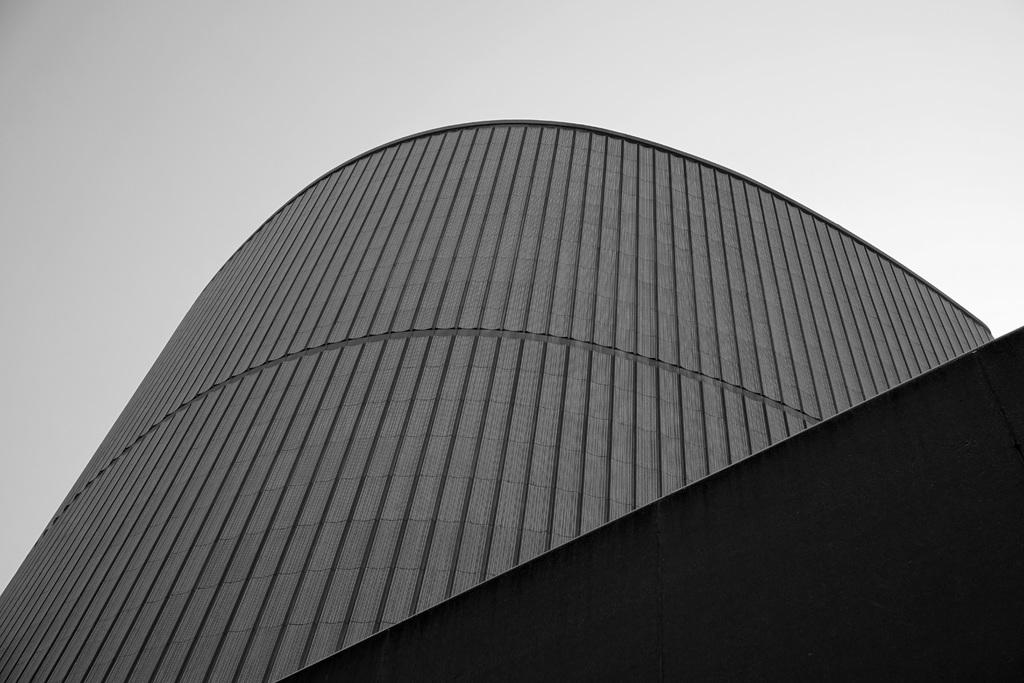What type of structure is present in the image? There is a building in the image. What part of the natural environment is visible in the image? The sky is visible in the image. How many daughters are present in the image? There are no people, including daughters, present in the image. 